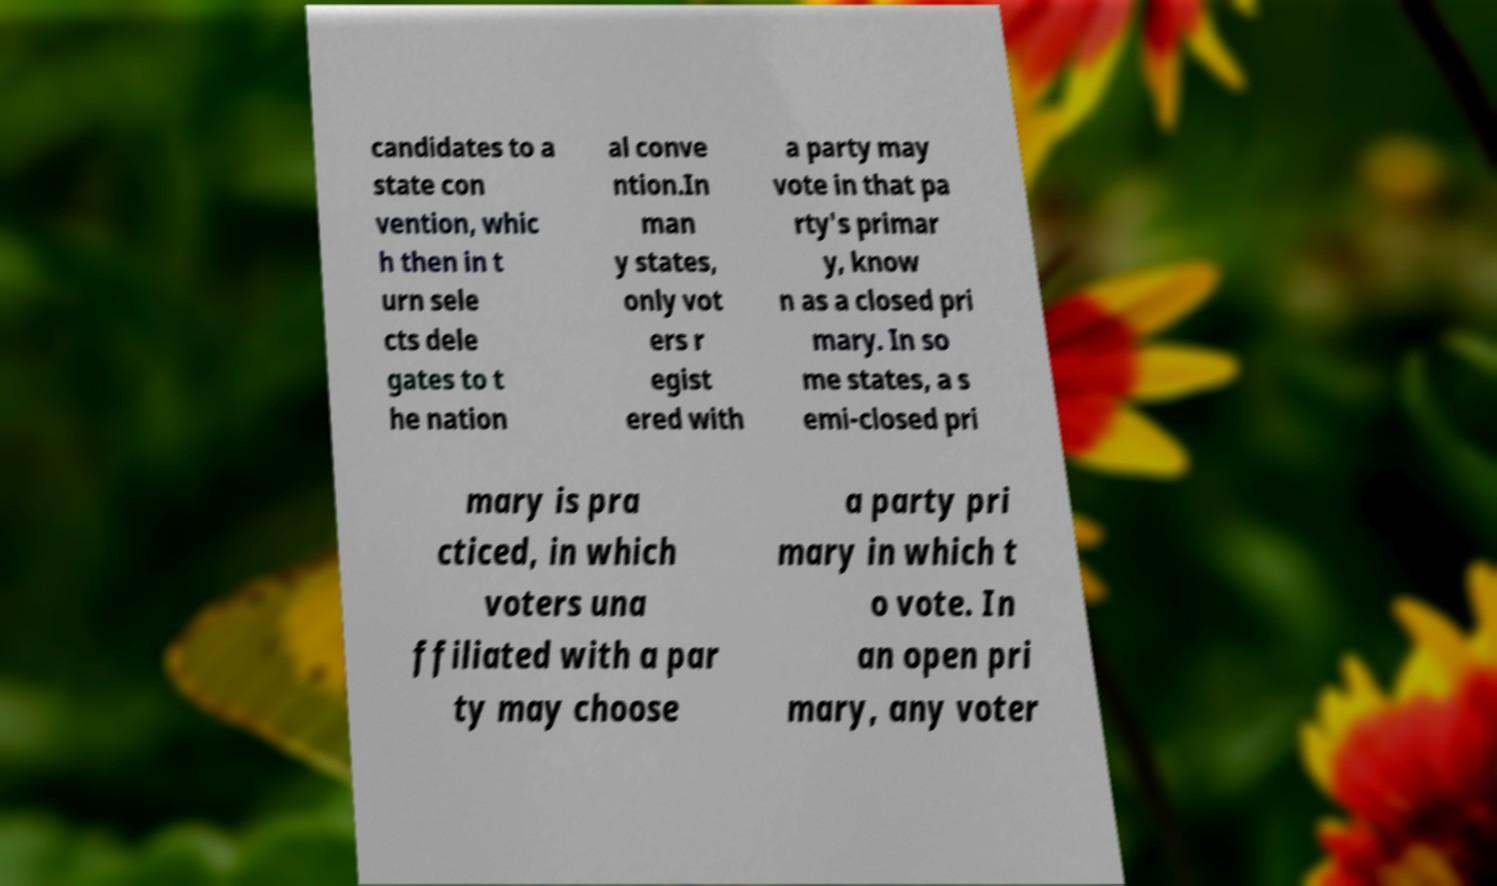Can you read and provide the text displayed in the image?This photo seems to have some interesting text. Can you extract and type it out for me? candidates to a state con vention, whic h then in t urn sele cts dele gates to t he nation al conve ntion.In man y states, only vot ers r egist ered with a party may vote in that pa rty's primar y, know n as a closed pri mary. In so me states, a s emi-closed pri mary is pra cticed, in which voters una ffiliated with a par ty may choose a party pri mary in which t o vote. In an open pri mary, any voter 